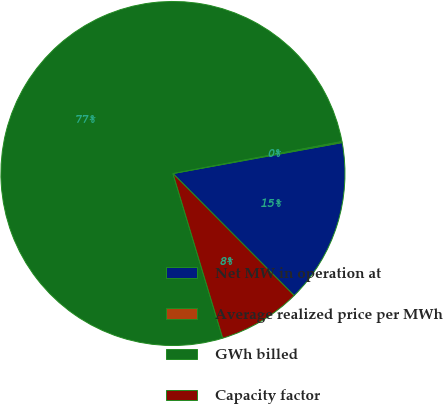<chart> <loc_0><loc_0><loc_500><loc_500><pie_chart><fcel>Net MW in operation at<fcel>Average realized price per MWh<fcel>GWh billed<fcel>Capacity factor<nl><fcel>15.43%<fcel>0.11%<fcel>76.69%<fcel>7.77%<nl></chart> 